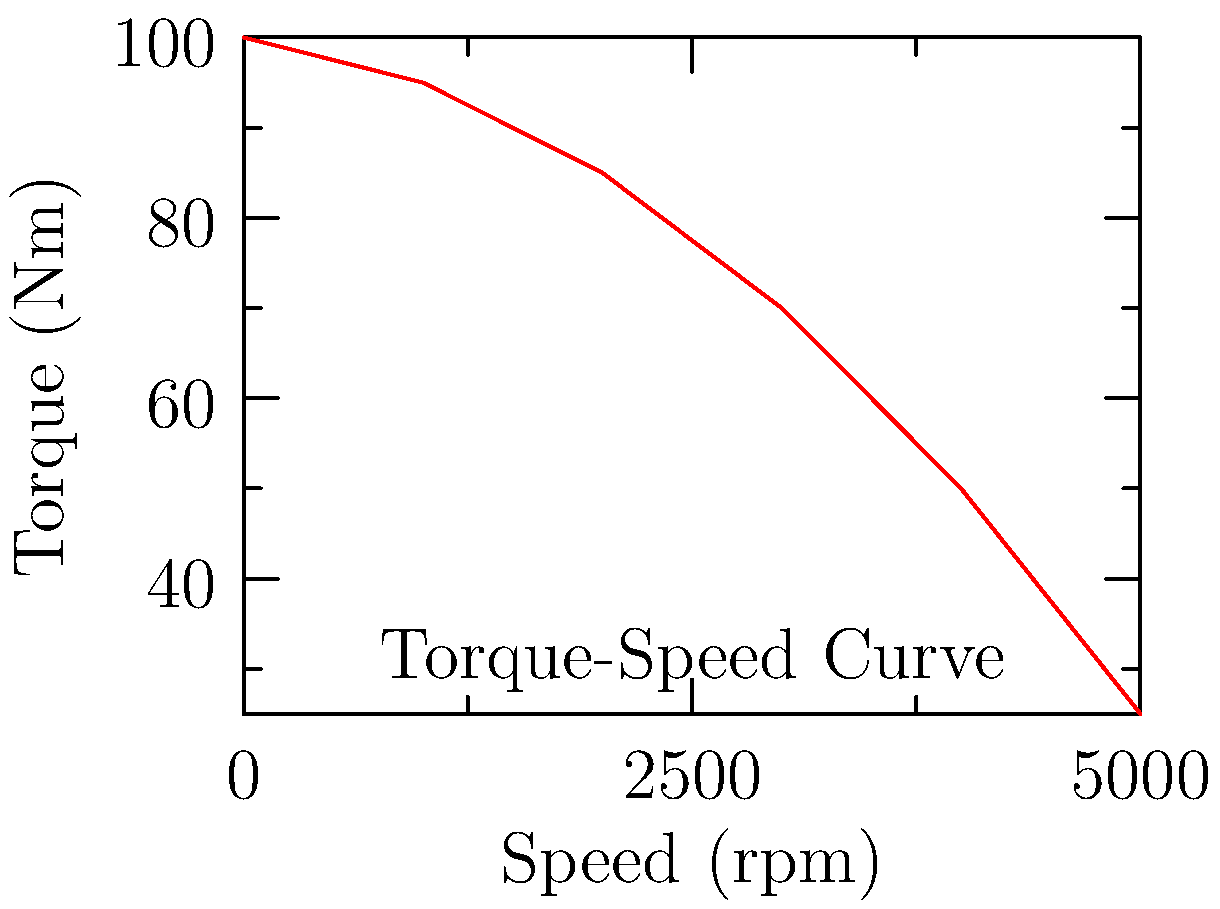Given the torque-speed curve of an electric motor shown above, calculate the maximum power output of the motor in kilowatts (kW). Assume the motor operates at its peak efficiency point, which occurs at 3000 rpm. Round your answer to the nearest whole number. To solve this problem, we'll follow these steps:

1) From the graph, we can see that at 3000 rpm, the torque is approximately 70 Nm.

2) The formula for power in a rotating system is:

   $$P = \tau \omega$$

   Where:
   $P$ is power in watts (W)
   $\tau$ is torque in Newton-meters (Nm)
   $\omega$ is angular velocity in radians per second (rad/s)

3) We need to convert rpm to rad/s:

   $$\omega = \frac{2\pi N}{60}$$

   Where $N$ is the speed in rpm.

   $$\omega = \frac{2\pi \cdot 3000}{60} = 314.16 \text{ rad/s}$$

4) Now we can calculate the power:

   $$P = 70 \text{ Nm} \cdot 314.16 \text{ rad/s} = 21991.2 \text{ W}$$

5) Convert watts to kilowatts:

   $$21991.2 \text{ W} = 21.9912 \text{ kW}$$

6) Rounding to the nearest whole number:

   $$21.9912 \text{ kW} \approx 22 \text{ kW}$$
Answer: 22 kW 